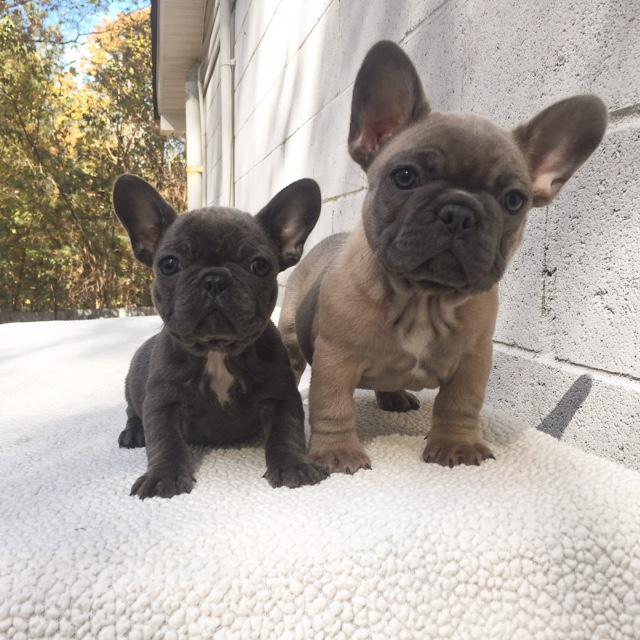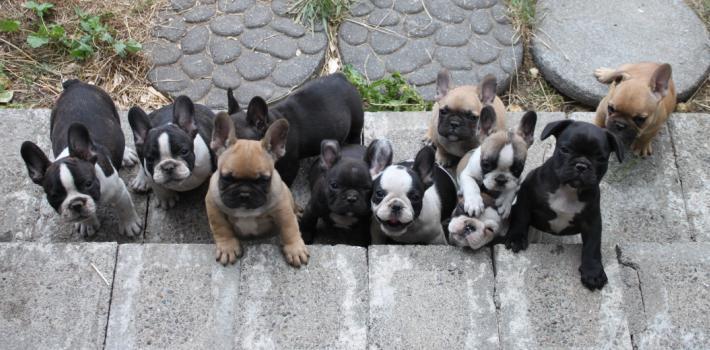The first image is the image on the left, the second image is the image on the right. Evaluate the accuracy of this statement regarding the images: "At least one image features a puppy on the grass.". Is it true? Answer yes or no. No. 